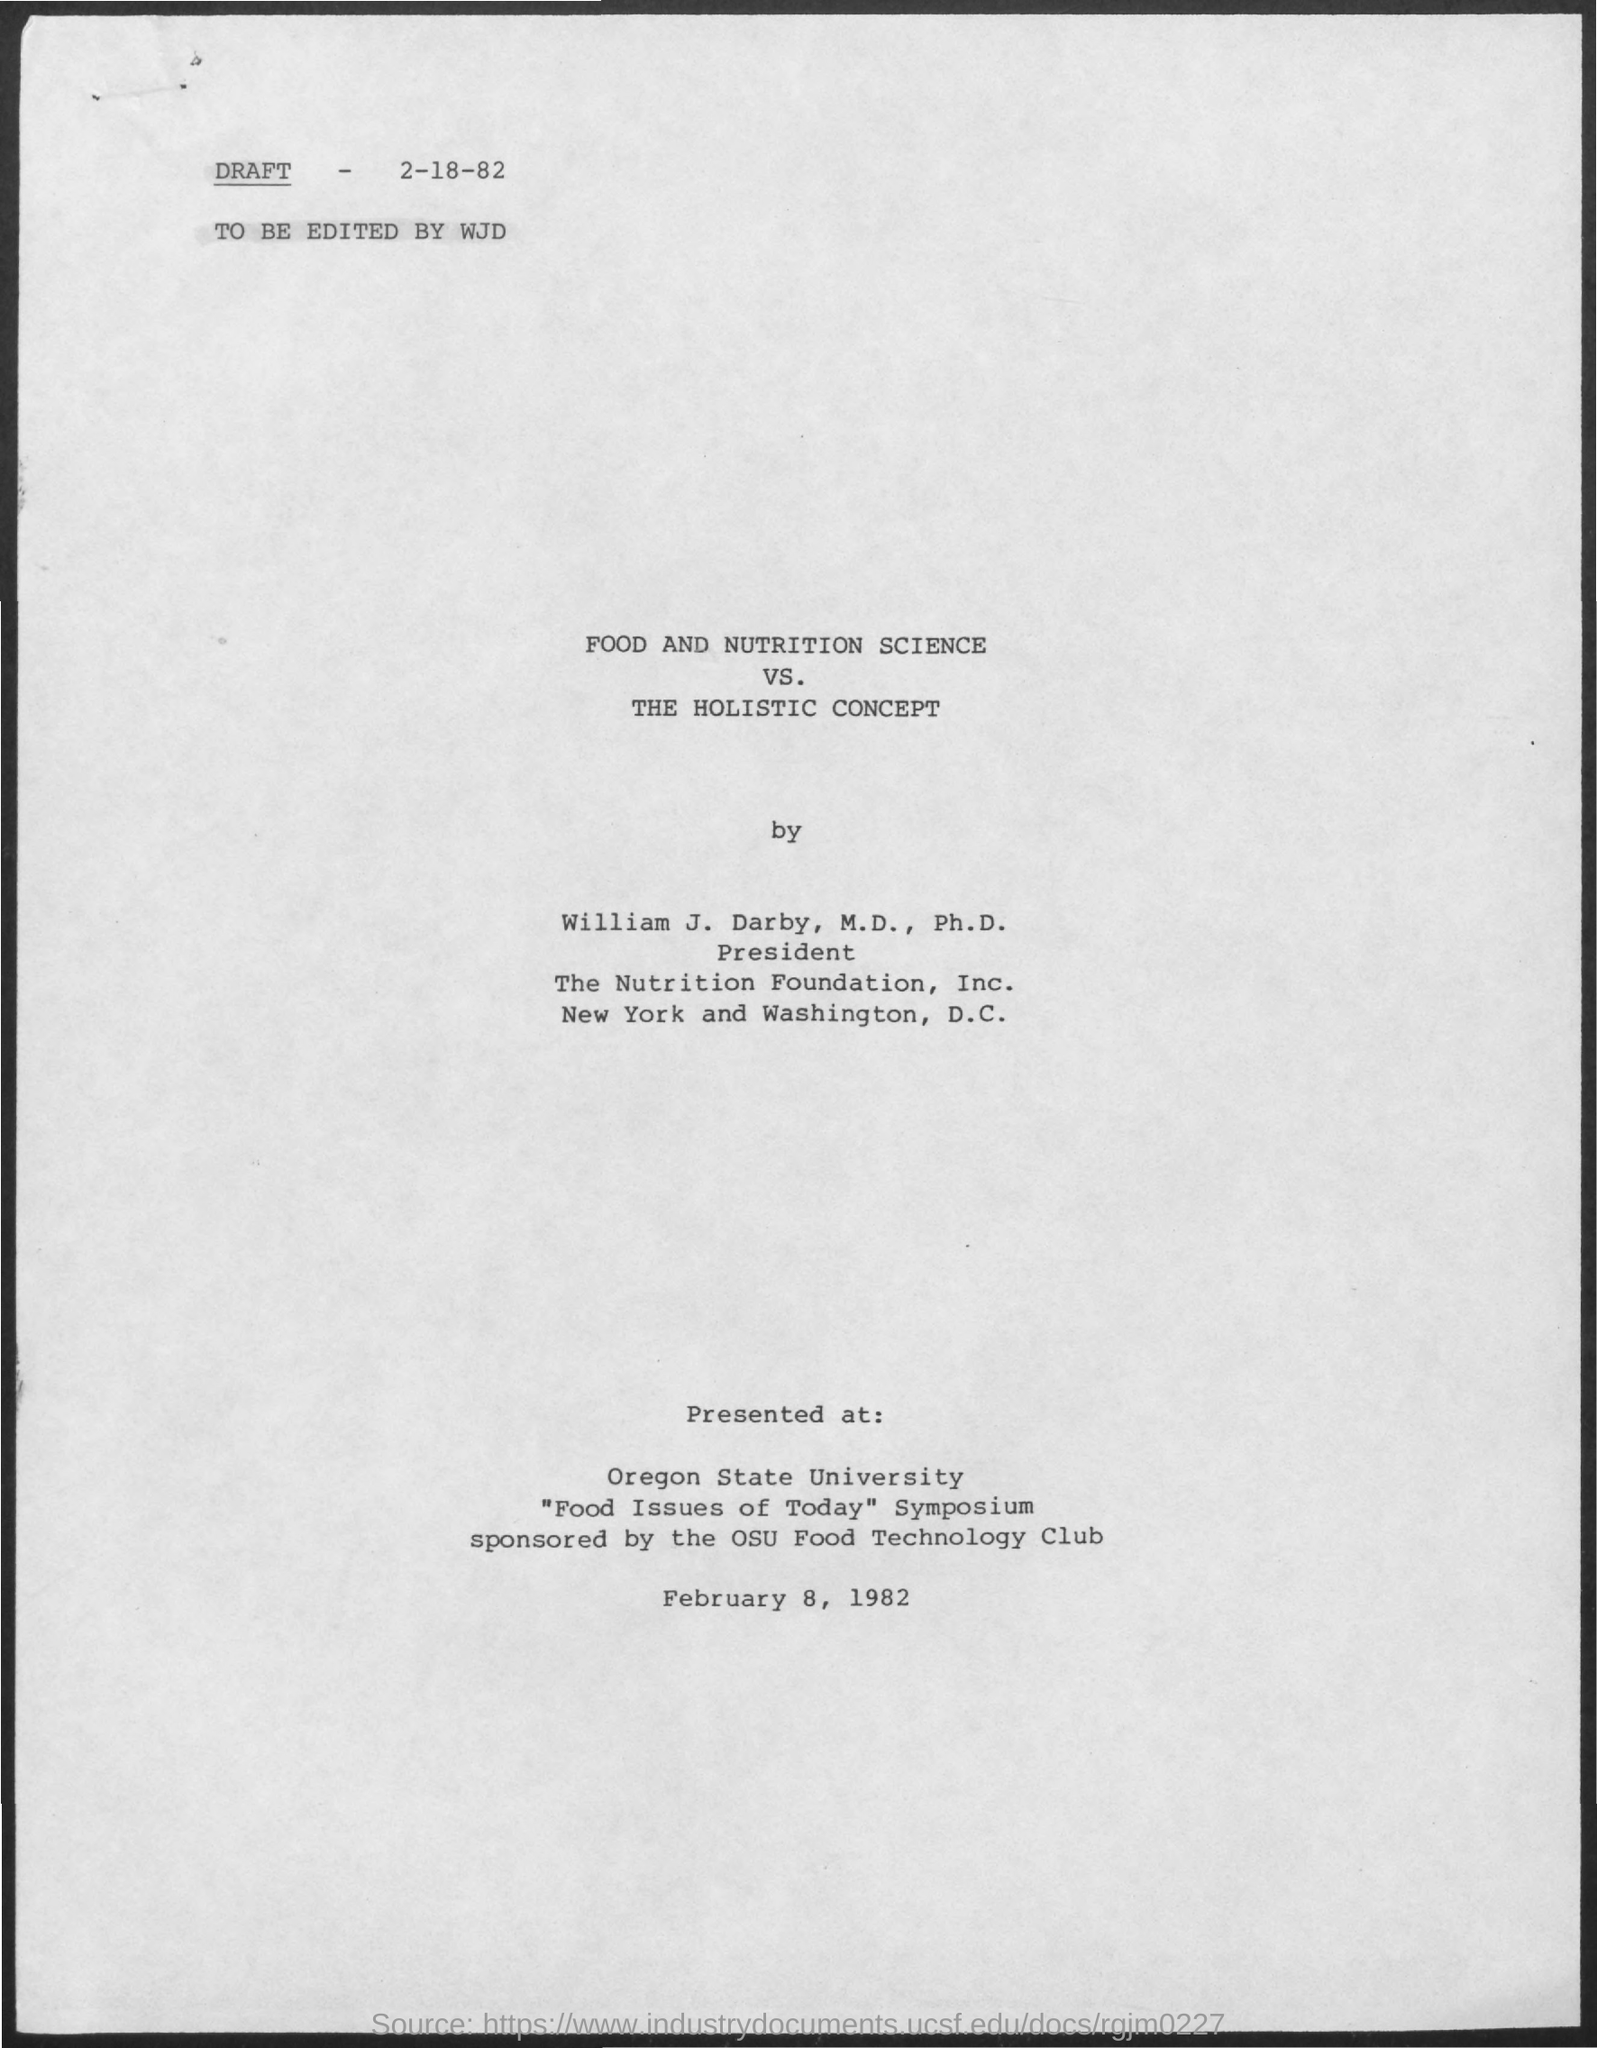Specify some key components in this picture. The date of the presentation mentioned in the given page is February 8, 1982. The draft was edited by WJD. The date mentioned at the top of the draft is February 18, 1982. The name of the university mentioned in the given form is Oregon State University. The holistic concept is a name of a concept that is being mentioned. 